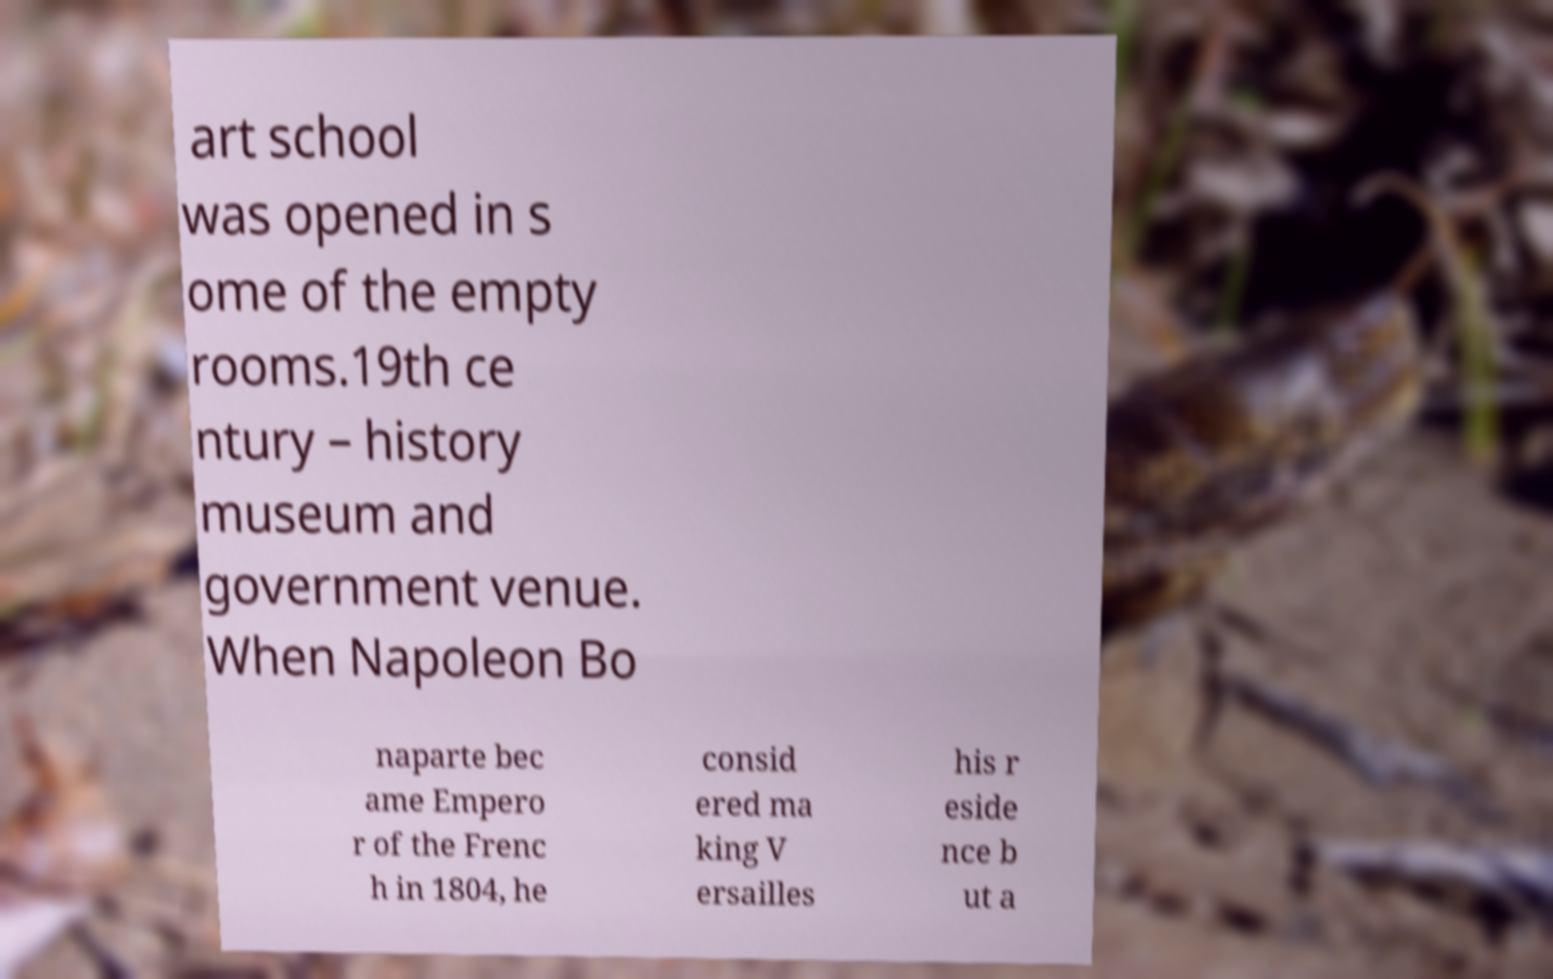Could you extract and type out the text from this image? art school was opened in s ome of the empty rooms.19th ce ntury – history museum and government venue. When Napoleon Bo naparte bec ame Empero r of the Frenc h in 1804, he consid ered ma king V ersailles his r eside nce b ut a 